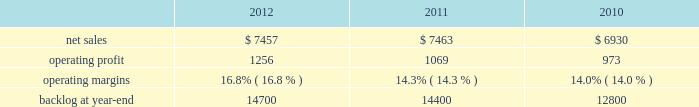2011 compared to 2010 is&gs 2019 net sales for 2011 decreased $ 540 million , or 5% ( 5 % ) , compared to 2010 .
The decrease primarily was attributable to lower volume of approximately $ 665 million due to the absence of the dris program that supported the 2010 u.s .
Census and a decline in activities on the jtrs program .
This decrease partially was offset by increased net sales on numerous programs .
Is&gs 2019 operating profit for 2011 increased $ 60 million , or 7% ( 7 % ) , compared to 2010 .
Operating profit increased approximately $ 180 million due to volume and the retirement of risks in 2011 and the absence of reserves recognized in 2010 on numerous programs ( including among others , odin ( about $ 60 million ) and twic and automated flight service station programs ) .
The increases in operating profit partially were offset by the absence of the dris program and a decline in activities on the jtrs program of about $ 120 million .
Adjustments not related to volume , including net profit rate adjustments described above , were approximately $ 130 million higher in 2011 compared to 2010 .
Backlog backlog decreased in 2012 compared to 2011 primarily due to the substantial completion of various programs in 2011 ( primarily odin , u.k .
Census , and jtrs ) .
The decrease in backlog during 2011 compared to 2010 mainly was due to declining activities on the jtrs program and several other smaller programs .
Trends we expect is&gs 2019 net sales to decline in 2013 in the mid single digit percentage range as compared to 2012 primarily due to the continued downturn in federal information technology budgets .
Operating profit is expected to decline in 2013 in the mid single digit percentage range consistent with the expected decline in net sales , resulting in margins that are comparable with 2012 results .
Missiles and fire control our mfc business segment provides air and missile defense systems ; tactical missiles and air-to-ground precision strike weapon systems ; fire control systems ; mission operations support , readiness , engineering support , and integration services ; logistics and other technical services ; and manned and unmanned ground vehicles .
Mfc 2019s major programs include pac-3 , thaad , multiple launch rocket system ( mlrs ) , hellfire , javelin , joint air-to-surface standoff missile ( jassm ) , apache fire control system ( apache ) , sniper ae , low altitude navigation and targeting infrared for night ( lantirn ae ) , and sof clss .
Mfc 2019s operating results included the following ( in millions ) : .
2012 compared to 2011 mfc 2019s net sales for 2012 were comparable to 2011 .
Net sales decreased approximately $ 130 million due to lower volume and risk retirements on various services programs , and about $ 60 million due to lower volume from fire control systems programs ( primarily sniper ae ; lantirn ae ; and apache ) .
The decreases largely were offset by higher net sales of approximately $ 95 million due to higher volume from tactical missile programs ( primarily javelin and hellfire ) and approximately $ 80 million for air and missile defense programs ( primarily pac-3 and thaad ) .
Mfc 2019s operating profit for 2012 increased $ 187 million , or 17% ( 17 % ) , compared to 2011 .
The increase was attributable to higher risk retirements and volume of about $ 95 million from tactical missile programs ( primarily javelin and hellfire ) ; increased risk retirements and volume of approximately $ 60 million for air and missile defense programs ( primarily thaad and pac-3 ) ; and about $ 45 million from a resolution of contractual matters .
Partially offsetting these increases was lower risk retirements and volume on various programs , including $ 25 million for services programs .
Adjustments not related to volume , including net profit booking rate adjustments and other matters described above , were approximately $ 145 million higher for 2012 compared to 2011. .
What is the growth rate in net sales for mfc in 2011? 
Computations: ((7463 - 6930) / 6930)
Answer: 0.07691. 